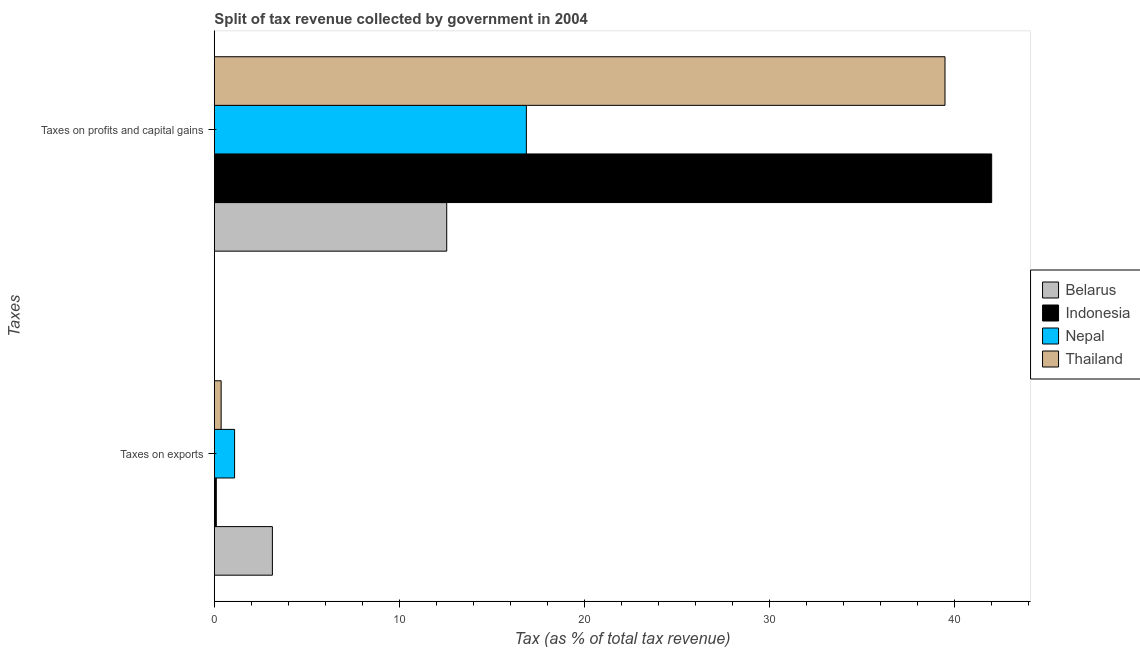How many groups of bars are there?
Provide a succinct answer. 2. How many bars are there on the 2nd tick from the bottom?
Provide a succinct answer. 4. What is the label of the 1st group of bars from the top?
Keep it short and to the point. Taxes on profits and capital gains. What is the percentage of revenue obtained from taxes on profits and capital gains in Belarus?
Offer a terse response. 12.56. Across all countries, what is the maximum percentage of revenue obtained from taxes on exports?
Offer a very short reply. 3.14. Across all countries, what is the minimum percentage of revenue obtained from taxes on profits and capital gains?
Offer a very short reply. 12.56. In which country was the percentage of revenue obtained from taxes on exports maximum?
Ensure brevity in your answer.  Belarus. In which country was the percentage of revenue obtained from taxes on profits and capital gains minimum?
Your answer should be very brief. Belarus. What is the total percentage of revenue obtained from taxes on profits and capital gains in the graph?
Make the answer very short. 110.92. What is the difference between the percentage of revenue obtained from taxes on exports in Belarus and that in Thailand?
Keep it short and to the point. 2.77. What is the difference between the percentage of revenue obtained from taxes on exports in Belarus and the percentage of revenue obtained from taxes on profits and capital gains in Thailand?
Offer a terse response. -36.35. What is the average percentage of revenue obtained from taxes on profits and capital gains per country?
Your answer should be compact. 27.73. What is the difference between the percentage of revenue obtained from taxes on profits and capital gains and percentage of revenue obtained from taxes on exports in Nepal?
Provide a short and direct response. 15.77. In how many countries, is the percentage of revenue obtained from taxes on profits and capital gains greater than 40 %?
Keep it short and to the point. 1. What is the ratio of the percentage of revenue obtained from taxes on profits and capital gains in Thailand to that in Nepal?
Ensure brevity in your answer.  2.34. What does the 3rd bar from the top in Taxes on profits and capital gains represents?
Provide a succinct answer. Indonesia. What does the 4th bar from the bottom in Taxes on profits and capital gains represents?
Provide a succinct answer. Thailand. Are all the bars in the graph horizontal?
Your answer should be very brief. Yes. What is the difference between two consecutive major ticks on the X-axis?
Your answer should be compact. 10. Are the values on the major ticks of X-axis written in scientific E-notation?
Keep it short and to the point. No. Does the graph contain any zero values?
Your answer should be very brief. No. Does the graph contain grids?
Your response must be concise. No. Where does the legend appear in the graph?
Provide a short and direct response. Center right. How many legend labels are there?
Offer a very short reply. 4. What is the title of the graph?
Your answer should be compact. Split of tax revenue collected by government in 2004. What is the label or title of the X-axis?
Provide a succinct answer. Tax (as % of total tax revenue). What is the label or title of the Y-axis?
Your answer should be compact. Taxes. What is the Tax (as % of total tax revenue) in Belarus in Taxes on exports?
Make the answer very short. 3.14. What is the Tax (as % of total tax revenue) in Indonesia in Taxes on exports?
Your response must be concise. 0.11. What is the Tax (as % of total tax revenue) in Nepal in Taxes on exports?
Offer a very short reply. 1.09. What is the Tax (as % of total tax revenue) in Thailand in Taxes on exports?
Your response must be concise. 0.37. What is the Tax (as % of total tax revenue) of Belarus in Taxes on profits and capital gains?
Provide a short and direct response. 12.56. What is the Tax (as % of total tax revenue) of Indonesia in Taxes on profits and capital gains?
Give a very brief answer. 42.01. What is the Tax (as % of total tax revenue) of Nepal in Taxes on profits and capital gains?
Keep it short and to the point. 16.86. What is the Tax (as % of total tax revenue) in Thailand in Taxes on profits and capital gains?
Provide a short and direct response. 39.49. Across all Taxes, what is the maximum Tax (as % of total tax revenue) in Belarus?
Provide a succinct answer. 12.56. Across all Taxes, what is the maximum Tax (as % of total tax revenue) in Indonesia?
Your response must be concise. 42.01. Across all Taxes, what is the maximum Tax (as % of total tax revenue) in Nepal?
Make the answer very short. 16.86. Across all Taxes, what is the maximum Tax (as % of total tax revenue) of Thailand?
Make the answer very short. 39.49. Across all Taxes, what is the minimum Tax (as % of total tax revenue) in Belarus?
Your answer should be very brief. 3.14. Across all Taxes, what is the minimum Tax (as % of total tax revenue) of Indonesia?
Ensure brevity in your answer.  0.11. Across all Taxes, what is the minimum Tax (as % of total tax revenue) of Nepal?
Offer a very short reply. 1.09. Across all Taxes, what is the minimum Tax (as % of total tax revenue) of Thailand?
Your response must be concise. 0.37. What is the total Tax (as % of total tax revenue) of Belarus in the graph?
Your answer should be compact. 15.69. What is the total Tax (as % of total tax revenue) of Indonesia in the graph?
Your response must be concise. 42.11. What is the total Tax (as % of total tax revenue) in Nepal in the graph?
Offer a very short reply. 17.96. What is the total Tax (as % of total tax revenue) of Thailand in the graph?
Ensure brevity in your answer.  39.85. What is the difference between the Tax (as % of total tax revenue) in Belarus in Taxes on exports and that in Taxes on profits and capital gains?
Provide a succinct answer. -9.42. What is the difference between the Tax (as % of total tax revenue) of Indonesia in Taxes on exports and that in Taxes on profits and capital gains?
Offer a terse response. -41.9. What is the difference between the Tax (as % of total tax revenue) of Nepal in Taxes on exports and that in Taxes on profits and capital gains?
Provide a short and direct response. -15.77. What is the difference between the Tax (as % of total tax revenue) of Thailand in Taxes on exports and that in Taxes on profits and capital gains?
Provide a short and direct response. -39.12. What is the difference between the Tax (as % of total tax revenue) in Belarus in Taxes on exports and the Tax (as % of total tax revenue) in Indonesia in Taxes on profits and capital gains?
Give a very brief answer. -38.87. What is the difference between the Tax (as % of total tax revenue) in Belarus in Taxes on exports and the Tax (as % of total tax revenue) in Nepal in Taxes on profits and capital gains?
Keep it short and to the point. -13.73. What is the difference between the Tax (as % of total tax revenue) of Belarus in Taxes on exports and the Tax (as % of total tax revenue) of Thailand in Taxes on profits and capital gains?
Offer a terse response. -36.35. What is the difference between the Tax (as % of total tax revenue) of Indonesia in Taxes on exports and the Tax (as % of total tax revenue) of Nepal in Taxes on profits and capital gains?
Provide a succinct answer. -16.76. What is the difference between the Tax (as % of total tax revenue) in Indonesia in Taxes on exports and the Tax (as % of total tax revenue) in Thailand in Taxes on profits and capital gains?
Keep it short and to the point. -39.38. What is the difference between the Tax (as % of total tax revenue) in Nepal in Taxes on exports and the Tax (as % of total tax revenue) in Thailand in Taxes on profits and capital gains?
Your answer should be very brief. -38.39. What is the average Tax (as % of total tax revenue) in Belarus per Taxes?
Ensure brevity in your answer.  7.85. What is the average Tax (as % of total tax revenue) in Indonesia per Taxes?
Provide a short and direct response. 21.06. What is the average Tax (as % of total tax revenue) in Nepal per Taxes?
Your answer should be compact. 8.98. What is the average Tax (as % of total tax revenue) of Thailand per Taxes?
Give a very brief answer. 19.93. What is the difference between the Tax (as % of total tax revenue) of Belarus and Tax (as % of total tax revenue) of Indonesia in Taxes on exports?
Your answer should be very brief. 3.03. What is the difference between the Tax (as % of total tax revenue) of Belarus and Tax (as % of total tax revenue) of Nepal in Taxes on exports?
Provide a succinct answer. 2.04. What is the difference between the Tax (as % of total tax revenue) in Belarus and Tax (as % of total tax revenue) in Thailand in Taxes on exports?
Ensure brevity in your answer.  2.77. What is the difference between the Tax (as % of total tax revenue) in Indonesia and Tax (as % of total tax revenue) in Nepal in Taxes on exports?
Offer a very short reply. -0.99. What is the difference between the Tax (as % of total tax revenue) of Indonesia and Tax (as % of total tax revenue) of Thailand in Taxes on exports?
Ensure brevity in your answer.  -0.26. What is the difference between the Tax (as % of total tax revenue) of Nepal and Tax (as % of total tax revenue) of Thailand in Taxes on exports?
Provide a short and direct response. 0.73. What is the difference between the Tax (as % of total tax revenue) in Belarus and Tax (as % of total tax revenue) in Indonesia in Taxes on profits and capital gains?
Your response must be concise. -29.45. What is the difference between the Tax (as % of total tax revenue) in Belarus and Tax (as % of total tax revenue) in Nepal in Taxes on profits and capital gains?
Give a very brief answer. -4.31. What is the difference between the Tax (as % of total tax revenue) of Belarus and Tax (as % of total tax revenue) of Thailand in Taxes on profits and capital gains?
Provide a short and direct response. -26.93. What is the difference between the Tax (as % of total tax revenue) in Indonesia and Tax (as % of total tax revenue) in Nepal in Taxes on profits and capital gains?
Provide a short and direct response. 25.15. What is the difference between the Tax (as % of total tax revenue) in Indonesia and Tax (as % of total tax revenue) in Thailand in Taxes on profits and capital gains?
Your answer should be compact. 2.52. What is the difference between the Tax (as % of total tax revenue) in Nepal and Tax (as % of total tax revenue) in Thailand in Taxes on profits and capital gains?
Make the answer very short. -22.62. What is the ratio of the Tax (as % of total tax revenue) of Belarus in Taxes on exports to that in Taxes on profits and capital gains?
Your answer should be compact. 0.25. What is the ratio of the Tax (as % of total tax revenue) of Indonesia in Taxes on exports to that in Taxes on profits and capital gains?
Ensure brevity in your answer.  0. What is the ratio of the Tax (as % of total tax revenue) in Nepal in Taxes on exports to that in Taxes on profits and capital gains?
Your answer should be very brief. 0.06. What is the ratio of the Tax (as % of total tax revenue) in Thailand in Taxes on exports to that in Taxes on profits and capital gains?
Offer a very short reply. 0.01. What is the difference between the highest and the second highest Tax (as % of total tax revenue) of Belarus?
Keep it short and to the point. 9.42. What is the difference between the highest and the second highest Tax (as % of total tax revenue) in Indonesia?
Give a very brief answer. 41.9. What is the difference between the highest and the second highest Tax (as % of total tax revenue) in Nepal?
Offer a terse response. 15.77. What is the difference between the highest and the second highest Tax (as % of total tax revenue) of Thailand?
Keep it short and to the point. 39.12. What is the difference between the highest and the lowest Tax (as % of total tax revenue) in Belarus?
Offer a very short reply. 9.42. What is the difference between the highest and the lowest Tax (as % of total tax revenue) in Indonesia?
Keep it short and to the point. 41.9. What is the difference between the highest and the lowest Tax (as % of total tax revenue) in Nepal?
Provide a succinct answer. 15.77. What is the difference between the highest and the lowest Tax (as % of total tax revenue) in Thailand?
Provide a succinct answer. 39.12. 